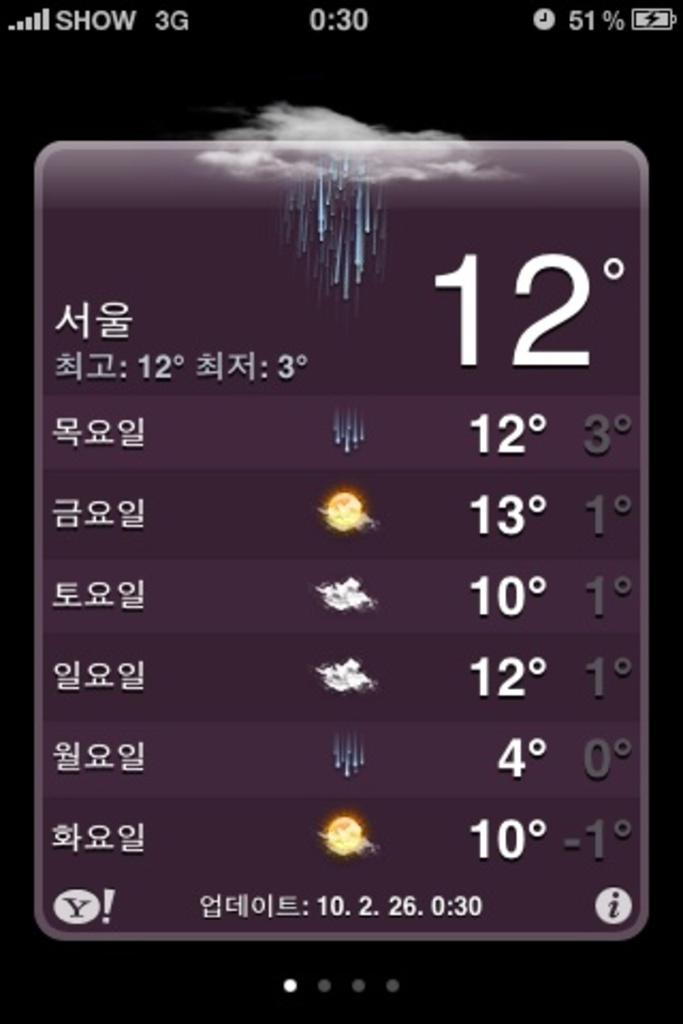Provide a one-sentence caption for the provided image. a weather app with the temps between 4 and 12 degrees. 